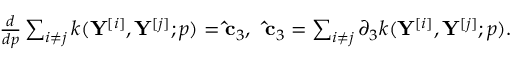Convert formula to latex. <formula><loc_0><loc_0><loc_500><loc_500>\begin{array} { r } { \frac { d } { d { p } } \sum _ { i \neq j } k ( Y ^ { [ i ] } , Y ^ { [ j ] } ; p ) = \hat { c } _ { 3 } , \, \hat { c } _ { 3 } = \sum _ { i \neq j } \partial _ { 3 } k ( Y ^ { [ i ] } , Y ^ { [ j ] } ; p ) . } \end{array}</formula> 